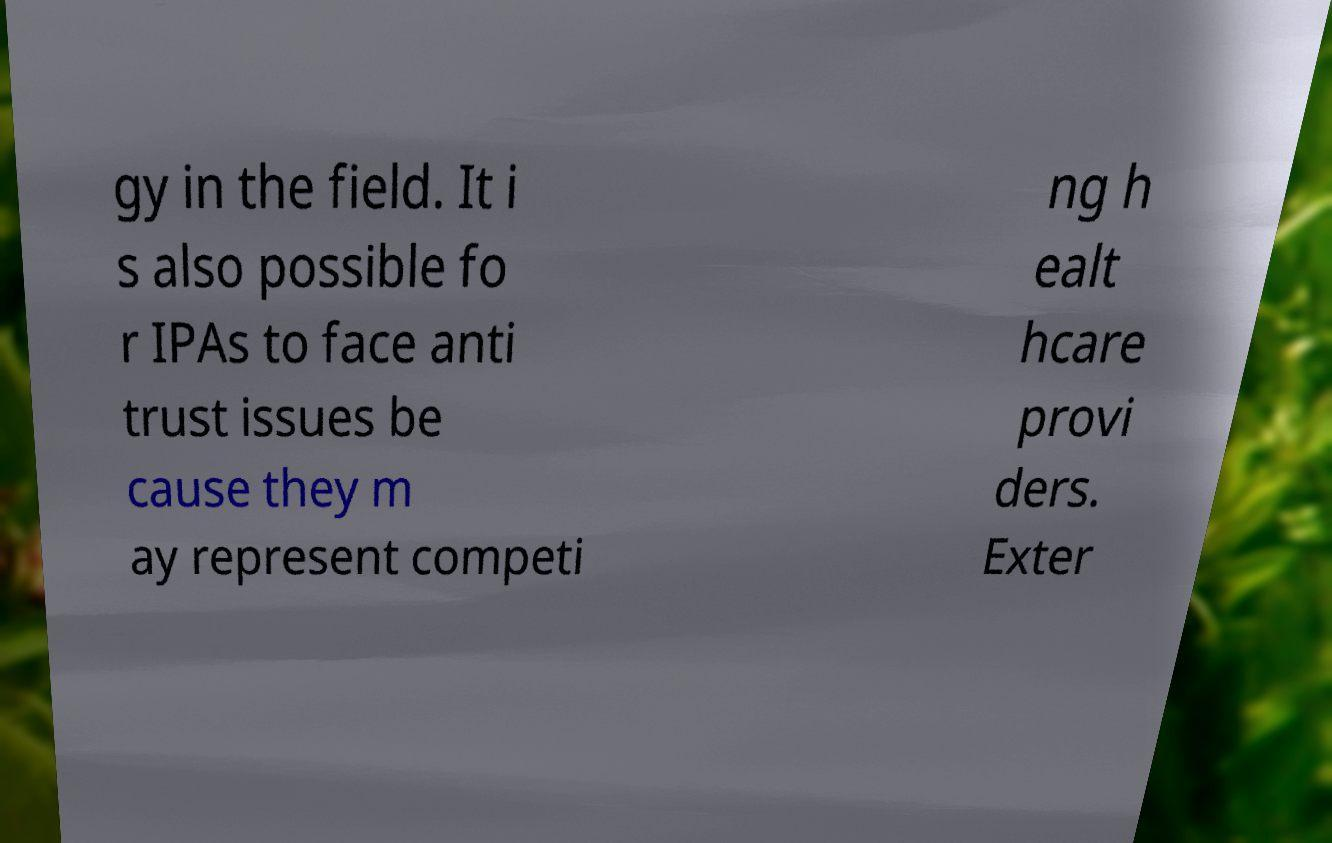Could you extract and type out the text from this image? gy in the field. It i s also possible fo r IPAs to face anti trust issues be cause they m ay represent competi ng h ealt hcare provi ders. Exter 